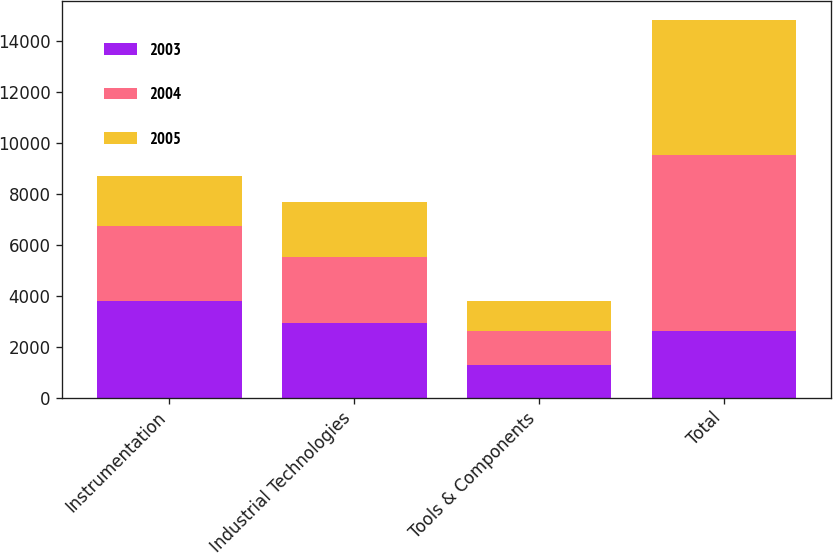<chart> <loc_0><loc_0><loc_500><loc_500><stacked_bar_chart><ecel><fcel>Instrumentation<fcel>Industrial Technologies<fcel>Tools & Components<fcel>Total<nl><fcel>2003<fcel>3782.1<fcel>2908.1<fcel>1294.5<fcel>2619.5<nl><fcel>2004<fcel>2963.5<fcel>2619.5<fcel>1306.3<fcel>6889.3<nl><fcel>2005<fcel>1939.7<fcel>2157<fcel>1197.2<fcel>5293.9<nl></chart> 